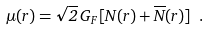Convert formula to latex. <formula><loc_0><loc_0><loc_500><loc_500>\mu ( r ) = \sqrt { 2 } \, G _ { F } \, [ N ( r ) + \overline { N } ( r ) ] \ .</formula> 